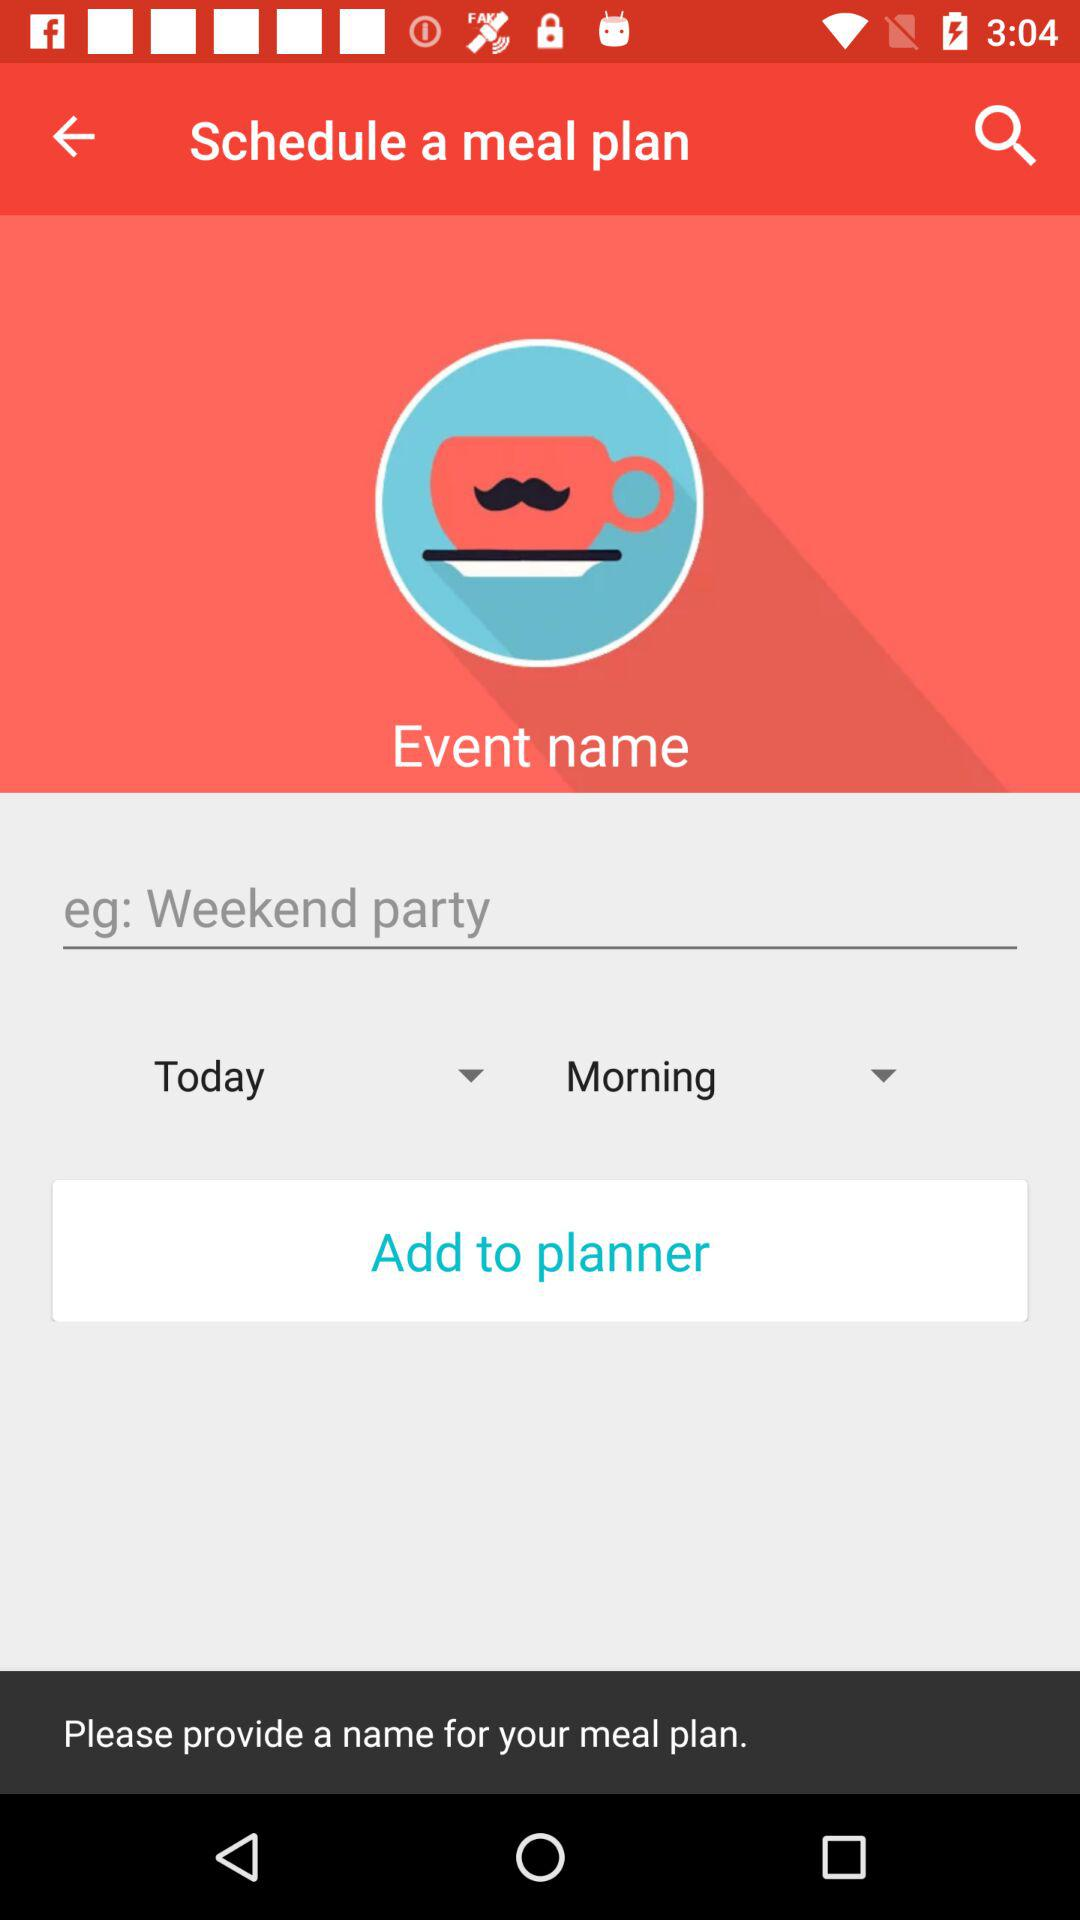What do we need to provide for our meal plan? You need to provide a name for your meal plan. 